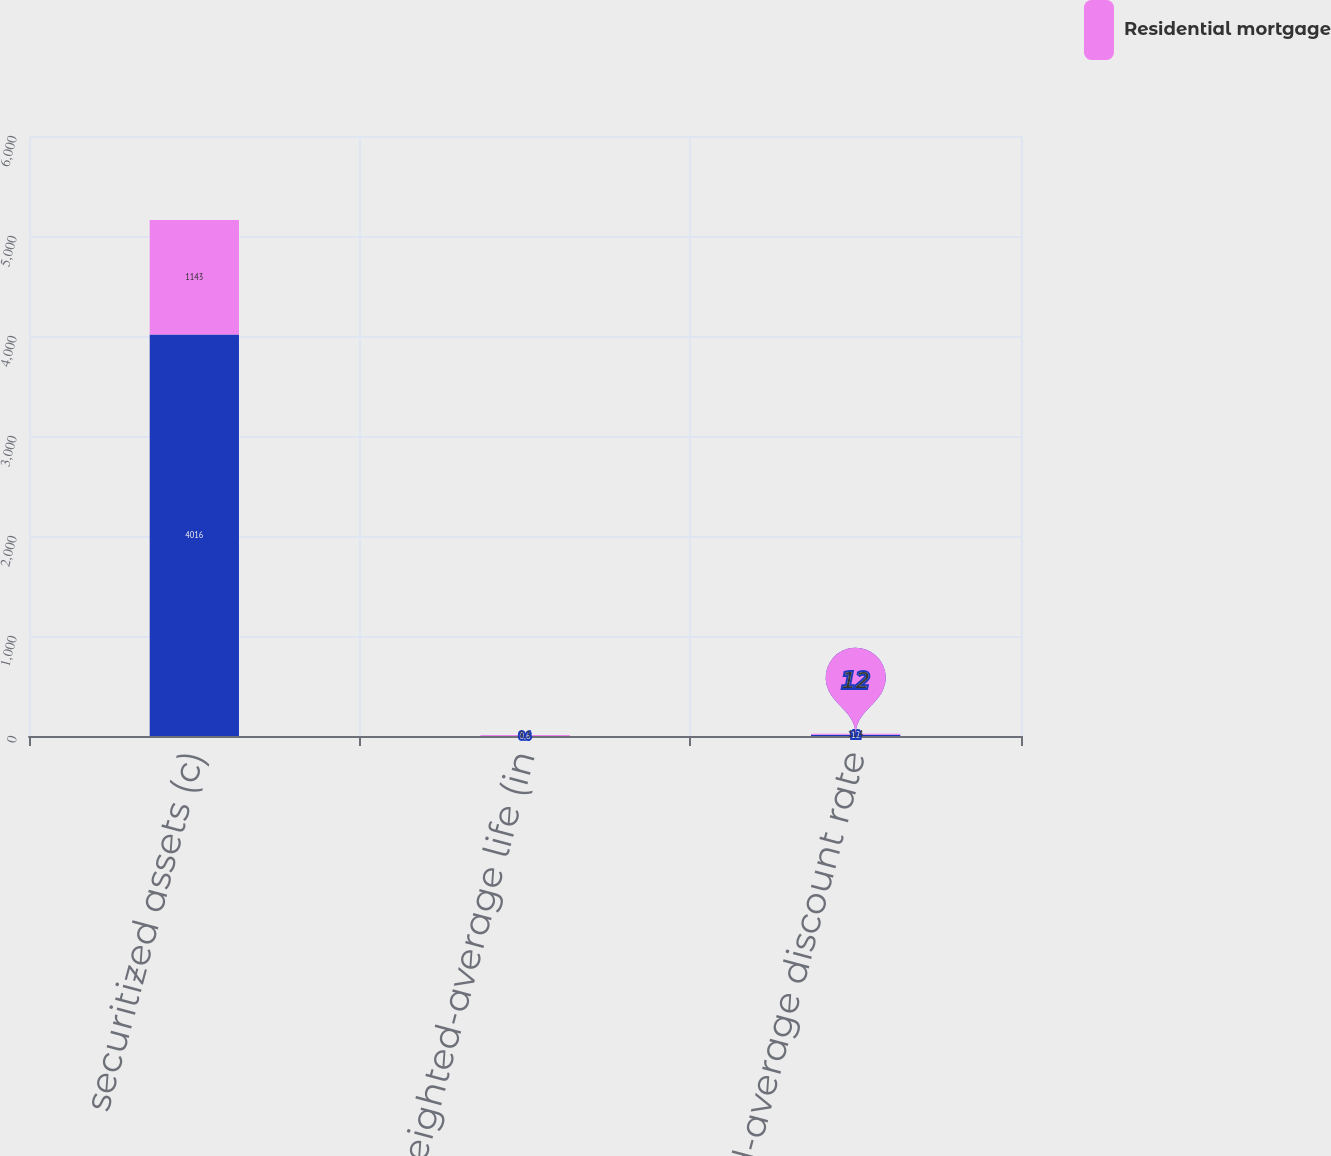Convert chart to OTSL. <chart><loc_0><loc_0><loc_500><loc_500><stacked_bar_chart><ecel><fcel>securitized assets (c)<fcel>Weighted-average life (in<fcel>Weighted-average discount rate<nl><fcel>nan<fcel>4016<fcel>0.6<fcel>12<nl><fcel>Residential mortgage<fcel>1143<fcel>8.3<fcel>11.4<nl></chart> 